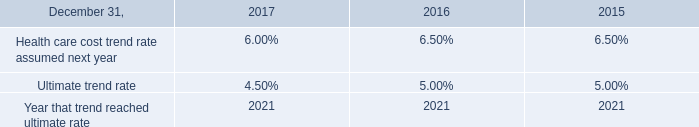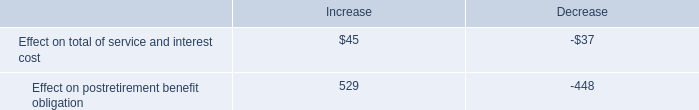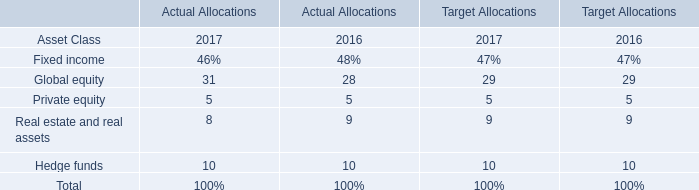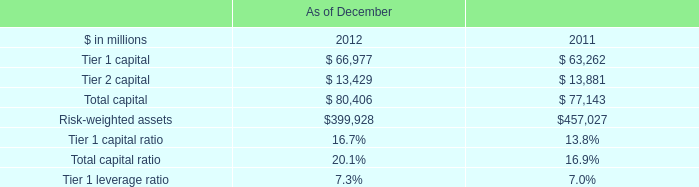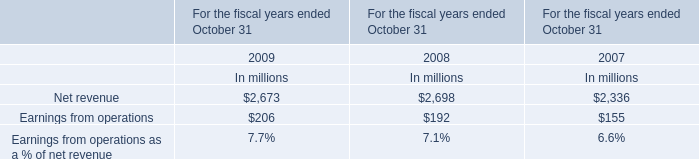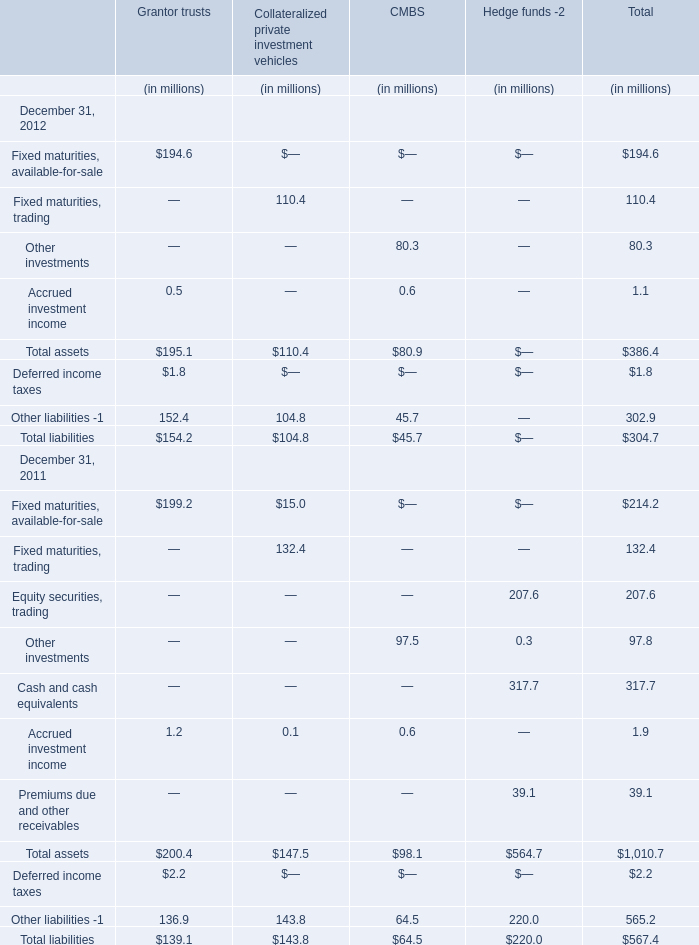Which elementhas the second largest number in 2012 for total? 
Answer: Total assets. 